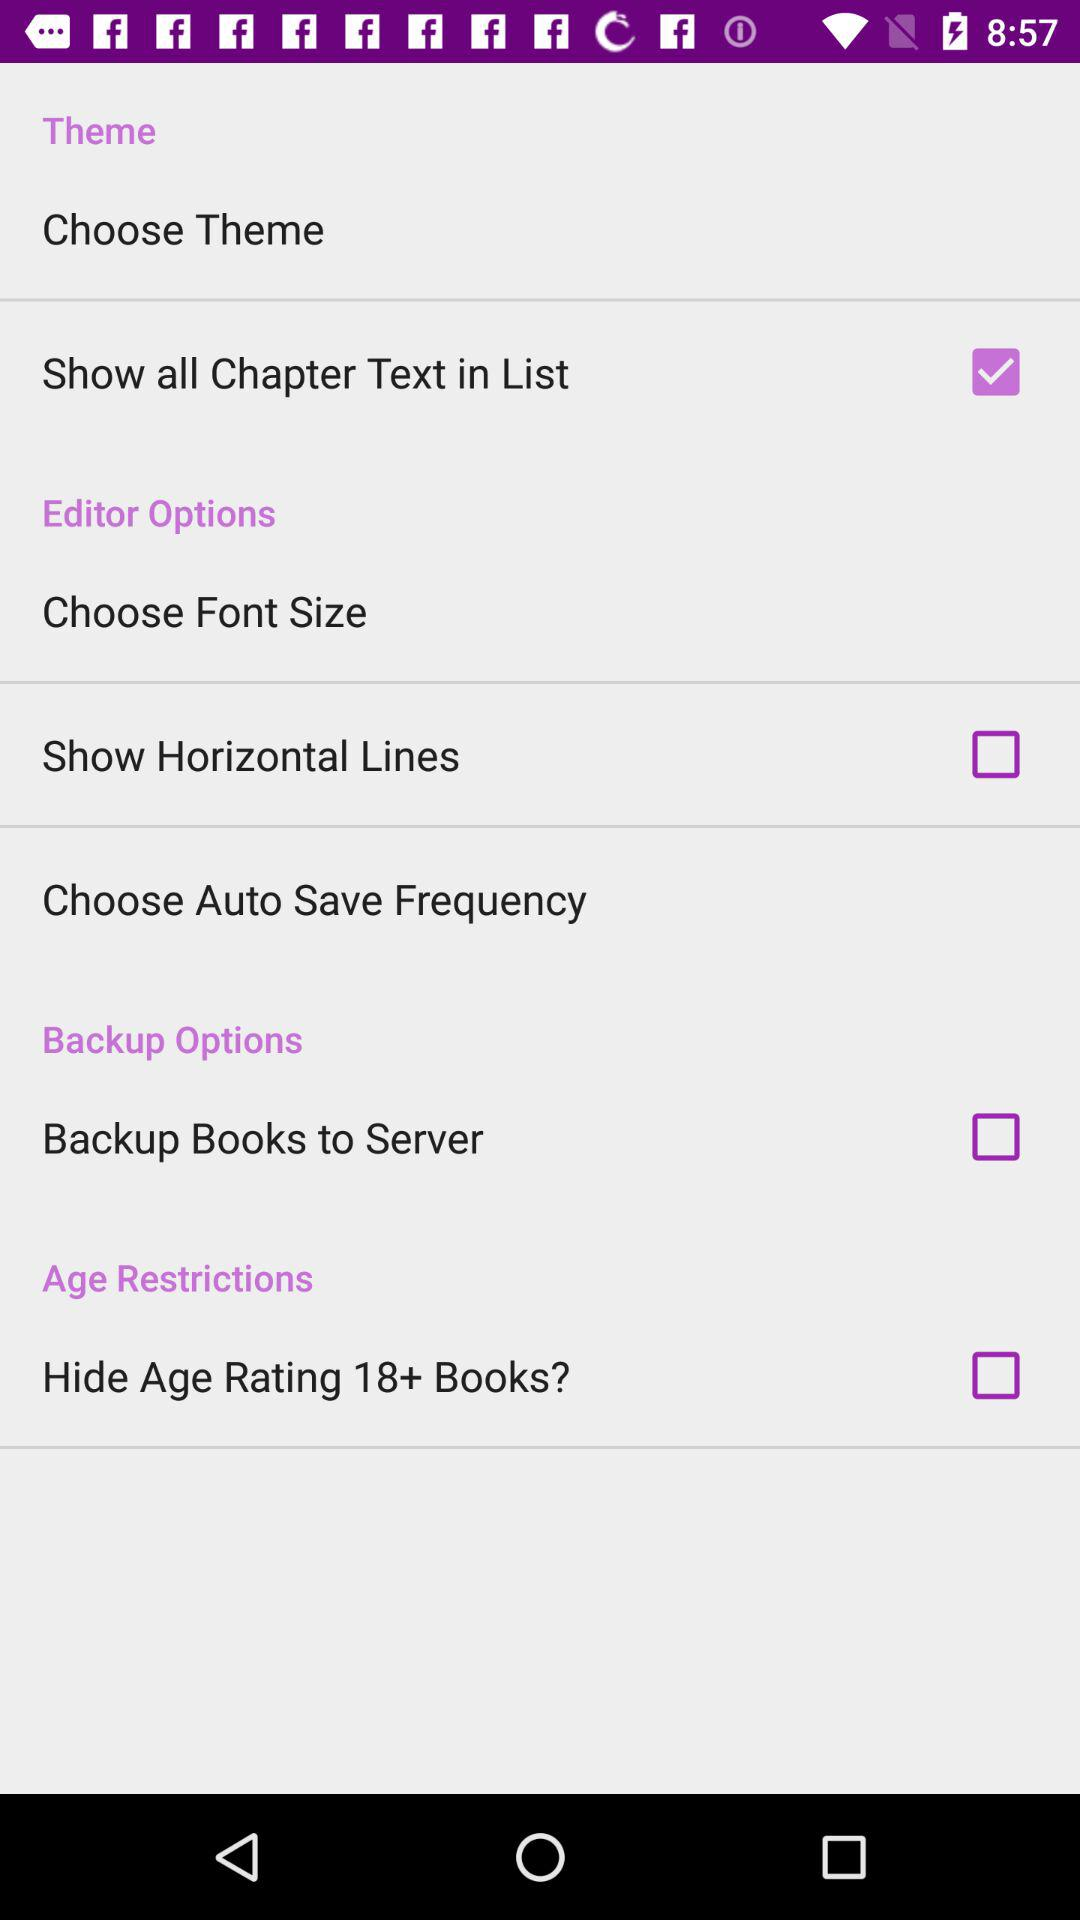What is the status of "Show Horizontal Lines"? The status is "off". 